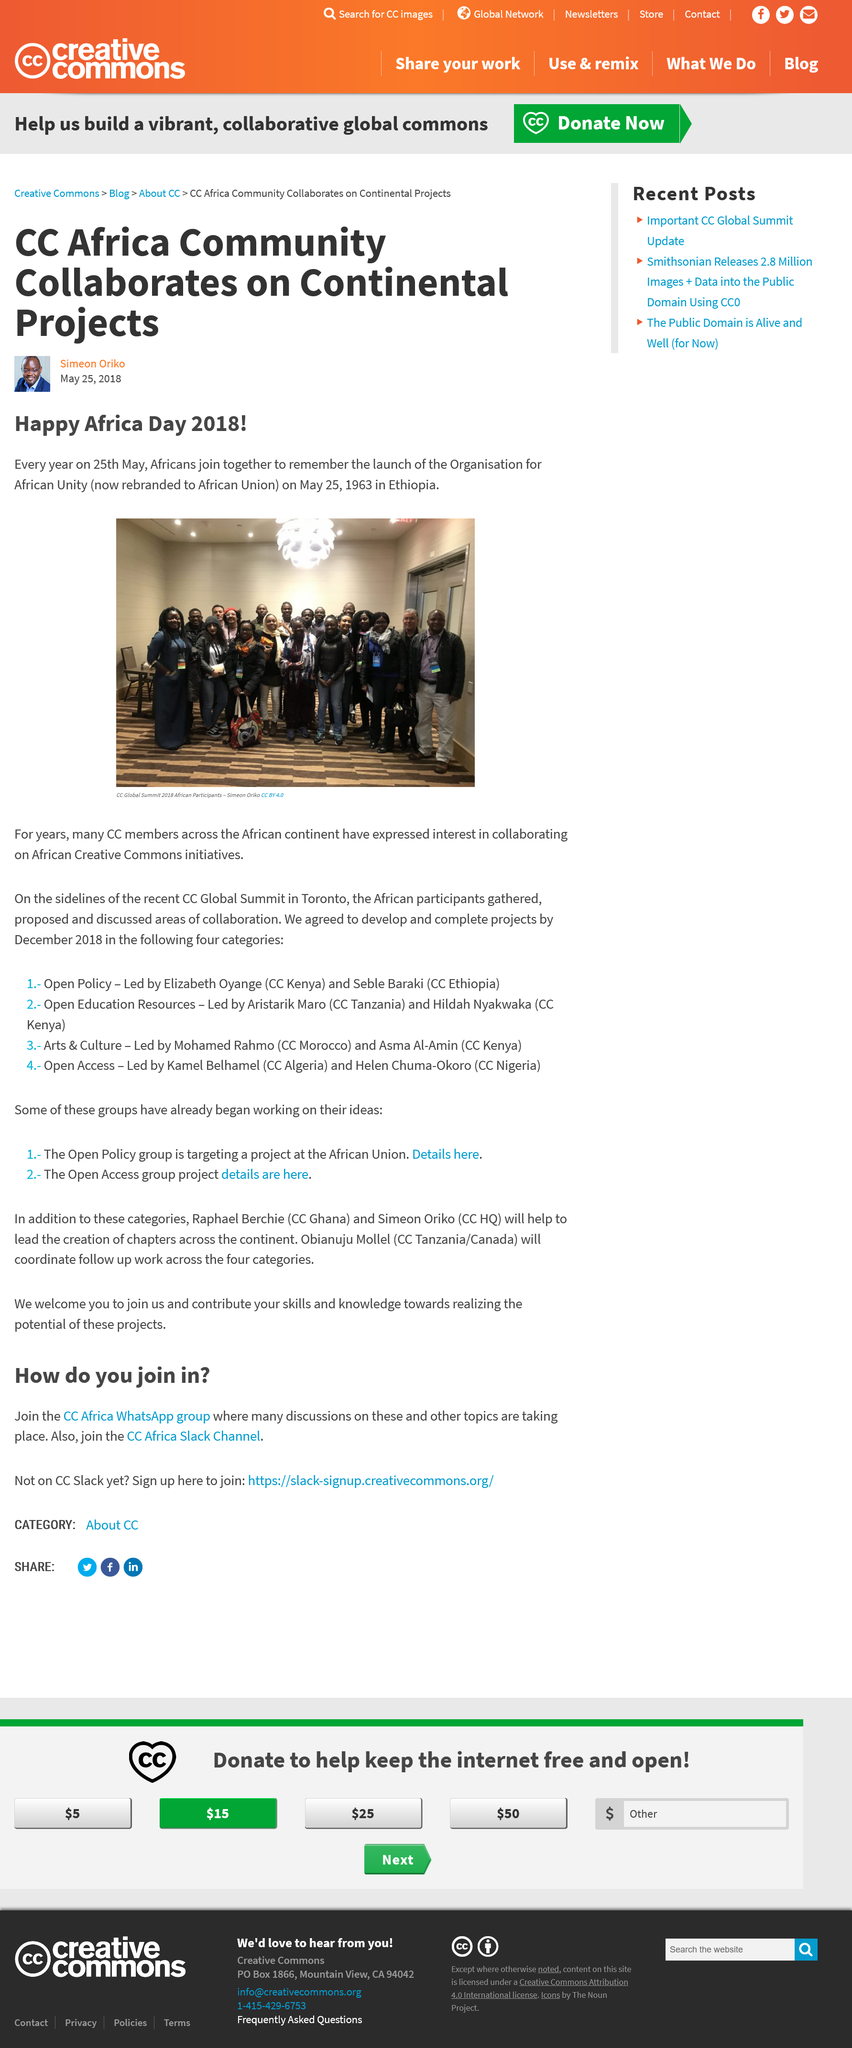Mention a couple of crucial points in this snapshot. On the 25th of May every year, Africans come together to commemorate the launch of the Organisation for African Unity. The CC Global Summit was recently held in Toronto. The individuals in the image are the participants of the CC Global Summit 2018 from the African continent. 